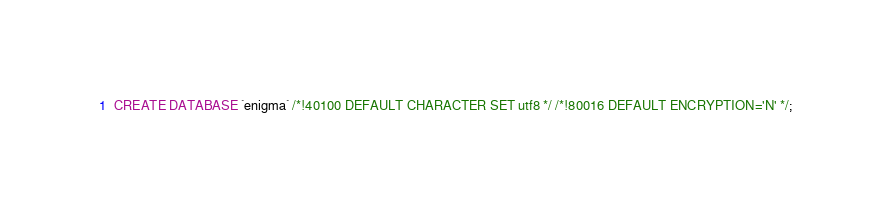<code> <loc_0><loc_0><loc_500><loc_500><_SQL_>CREATE DATABASE `enigma` /*!40100 DEFAULT CHARACTER SET utf8 */ /*!80016 DEFAULT ENCRYPTION='N' */;</code> 